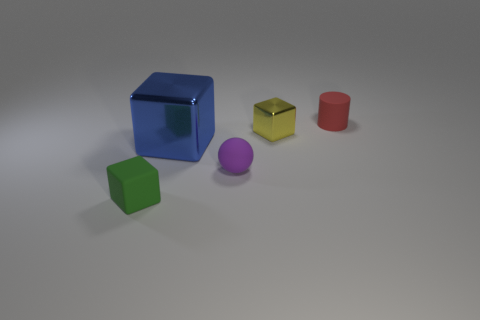There is a tiny cube that is behind the blue metal block; are there any tiny yellow metallic blocks right of it?
Your answer should be very brief. No. There is a rubber object behind the small purple sphere; is it the same shape as the purple thing that is to the left of the small yellow cube?
Ensure brevity in your answer.  No. Does the small block that is behind the green block have the same material as the small cube on the left side of the tiny yellow shiny cube?
Provide a succinct answer. No. There is a small block to the right of the cube left of the large blue metallic object; what is its material?
Provide a short and direct response. Metal. The small matte object that is behind the tiny block right of the small rubber object that is in front of the matte sphere is what shape?
Keep it short and to the point. Cylinder. What material is the big blue thing that is the same shape as the tiny yellow metallic object?
Ensure brevity in your answer.  Metal. How many big shiny cubes are there?
Keep it short and to the point. 1. There is a small thing right of the small metallic cube; what shape is it?
Give a very brief answer. Cylinder. What color is the cube that is to the right of the shiny block that is in front of the small cube to the right of the green block?
Provide a succinct answer. Yellow. There is another object that is made of the same material as the small yellow thing; what shape is it?
Make the answer very short. Cube. 